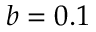<formula> <loc_0><loc_0><loc_500><loc_500>b = 0 . 1</formula> 